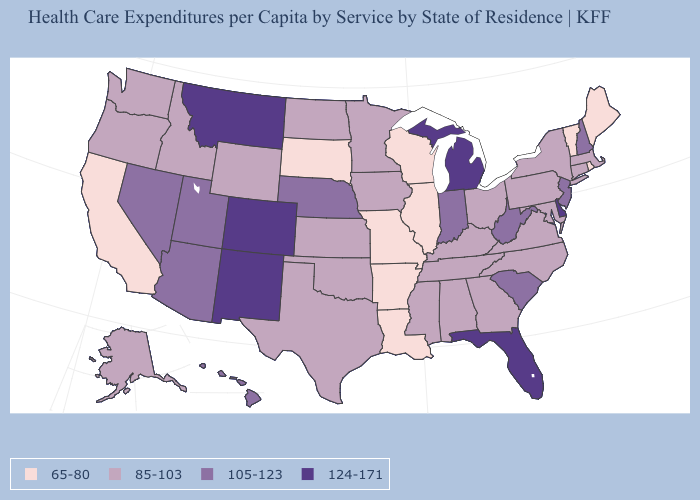Among the states that border Mississippi , does Louisiana have the lowest value?
Give a very brief answer. Yes. What is the value of Oklahoma?
Give a very brief answer. 85-103. What is the value of Montana?
Quick response, please. 124-171. Name the states that have a value in the range 65-80?
Answer briefly. Arkansas, California, Illinois, Louisiana, Maine, Missouri, Rhode Island, South Dakota, Vermont, Wisconsin. What is the value of Michigan?
Short answer required. 124-171. Which states have the lowest value in the USA?
Write a very short answer. Arkansas, California, Illinois, Louisiana, Maine, Missouri, Rhode Island, South Dakota, Vermont, Wisconsin. Which states have the lowest value in the Northeast?
Keep it brief. Maine, Rhode Island, Vermont. Name the states that have a value in the range 105-123?
Keep it brief. Arizona, Hawaii, Indiana, Nebraska, Nevada, New Hampshire, New Jersey, South Carolina, Utah, West Virginia. What is the lowest value in the Northeast?
Write a very short answer. 65-80. Does the map have missing data?
Be succinct. No. Name the states that have a value in the range 85-103?
Answer briefly. Alabama, Alaska, Connecticut, Georgia, Idaho, Iowa, Kansas, Kentucky, Maryland, Massachusetts, Minnesota, Mississippi, New York, North Carolina, North Dakota, Ohio, Oklahoma, Oregon, Pennsylvania, Tennessee, Texas, Virginia, Washington, Wyoming. What is the value of Georgia?
Be succinct. 85-103. Among the states that border Alabama , does Mississippi have the lowest value?
Write a very short answer. Yes. What is the value of Michigan?
Answer briefly. 124-171. Name the states that have a value in the range 85-103?
Quick response, please. Alabama, Alaska, Connecticut, Georgia, Idaho, Iowa, Kansas, Kentucky, Maryland, Massachusetts, Minnesota, Mississippi, New York, North Carolina, North Dakota, Ohio, Oklahoma, Oregon, Pennsylvania, Tennessee, Texas, Virginia, Washington, Wyoming. 